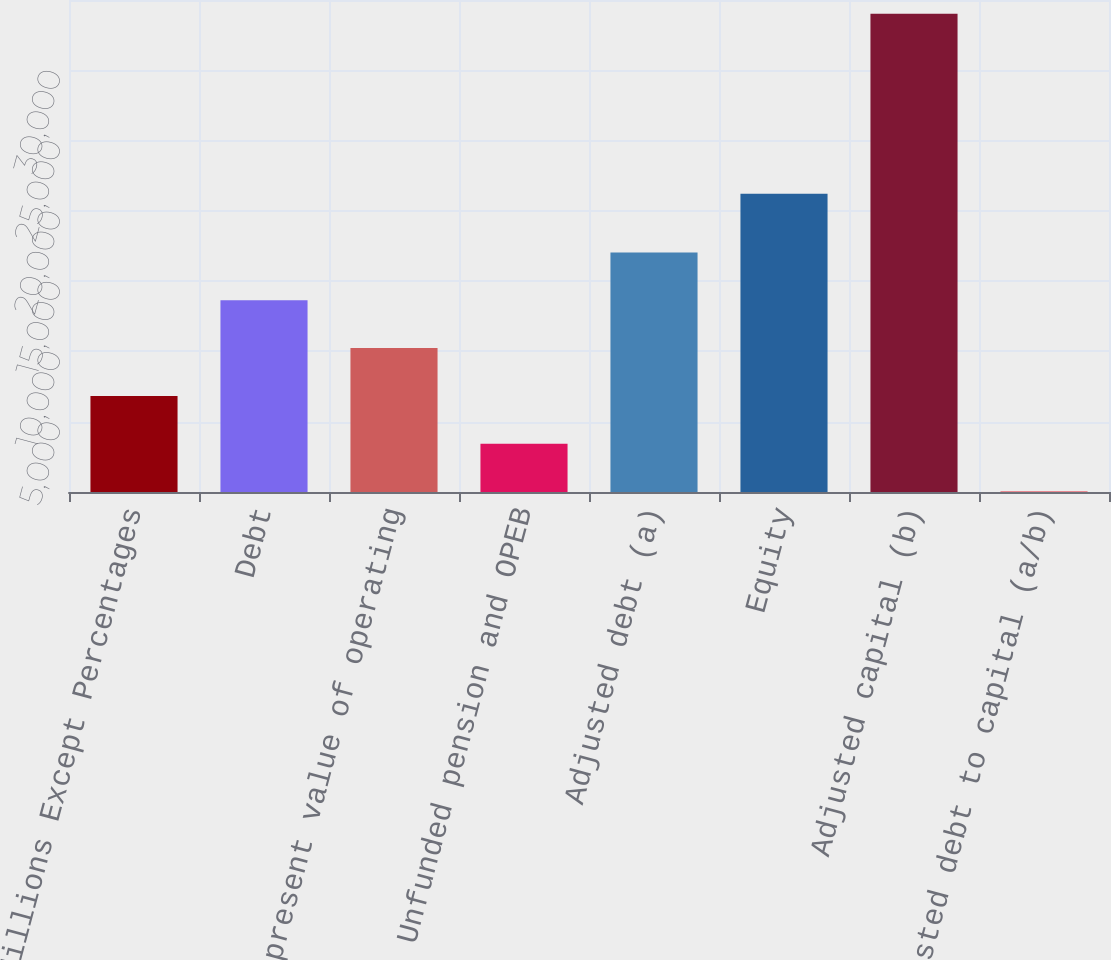Convert chart to OTSL. <chart><loc_0><loc_0><loc_500><loc_500><bar_chart><fcel>Millions Except Percentages<fcel>Debt<fcel>Net present value of operating<fcel>Unfunded pension and OPEB<fcel>Adjusted debt (a)<fcel>Equity<fcel>Adjusted capital (b)<fcel>Adjusted debt to capital (a/b)<nl><fcel>6835.88<fcel>13634.2<fcel>10235<fcel>3436.74<fcel>17033.3<fcel>21225<fcel>34029<fcel>37.6<nl></chart> 